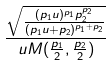Convert formula to latex. <formula><loc_0><loc_0><loc_500><loc_500>\frac { \sqrt { \frac { ( p _ { 1 } u ) ^ { p _ { 1 } } p _ { 2 } ^ { p _ { 2 } } } { ( p _ { 1 } u + p _ { 2 } ) ^ { p _ { 1 } + p _ { 2 } } } } } { u M ( \frac { p _ { 1 } } { 2 } , \frac { p _ { 2 } } { 2 } ) }</formula> 